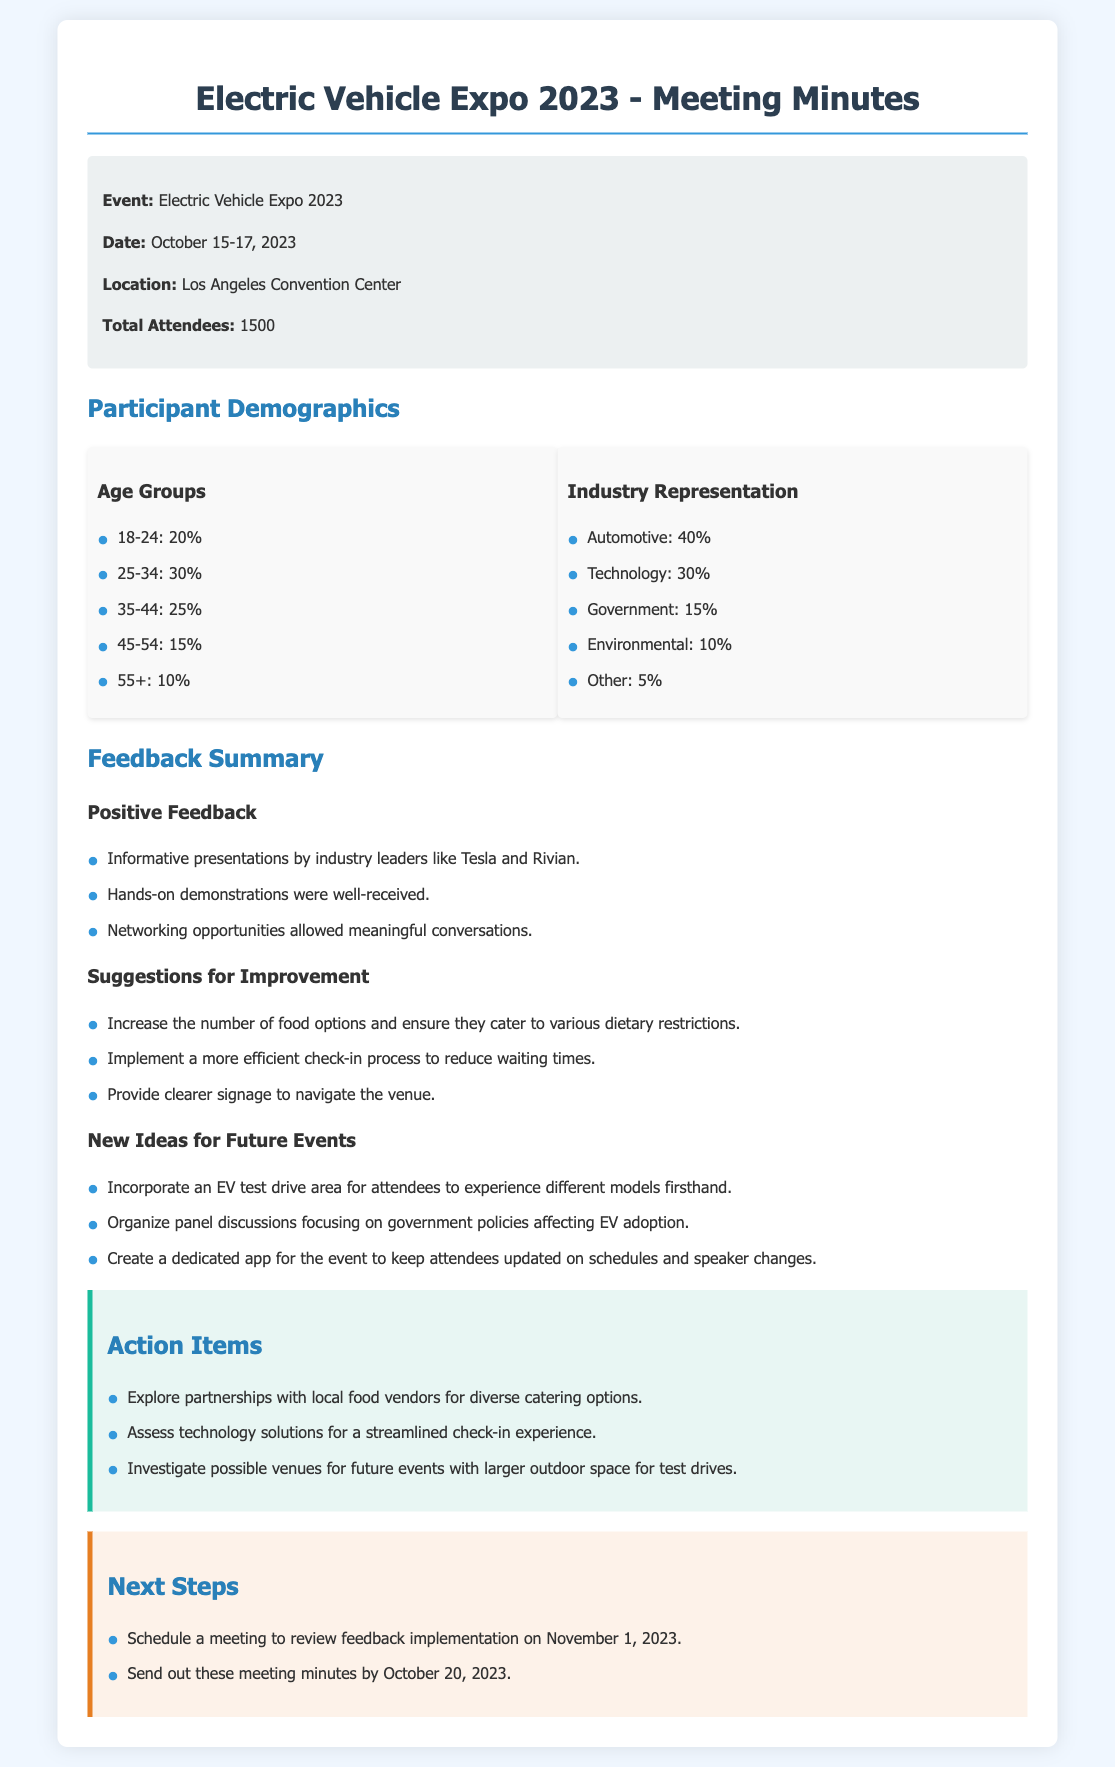what is the total number of attendees? The total number of attendees is mentioned in the event info section of the document.
Answer: 1500 what are the age groups represented at the expo? The age groups and their percentages are listed in the Participant Demographics section.
Answer: 18-24, 25-34, 35-44, 45-54, 55+ what was one positive feedback received? The positive feedback section contains multiple praises about the event.
Answer: Informative presentations by industry leaders like Tesla and Rivian how many suggestions for improvement were listed? The suggestions for improvement section enumerates the points that participants provided.
Answer: 3 what idea was proposed for future events? The new ideas for future events section lists suggestions made by participants.
Answer: Incorporate an EV test drive area for attendees what action item relates to food options? The action items section includes tasks based on the feedback received about food.
Answer: Explore partnerships with local food vendors for diverse catering options what is the next step scheduled for November 1, 2023? The next steps section outlines upcoming meetings and deadlines.
Answer: Schedule a meeting to review feedback implementation who conducted presentations at the event? The positive feedback section mentions the industry leaders who presented.
Answer: Tesla and Rivian what percentage of attendees were from the automotive industry? The industry representation section provides the percentage breakdown of attendees.
Answer: 40% 